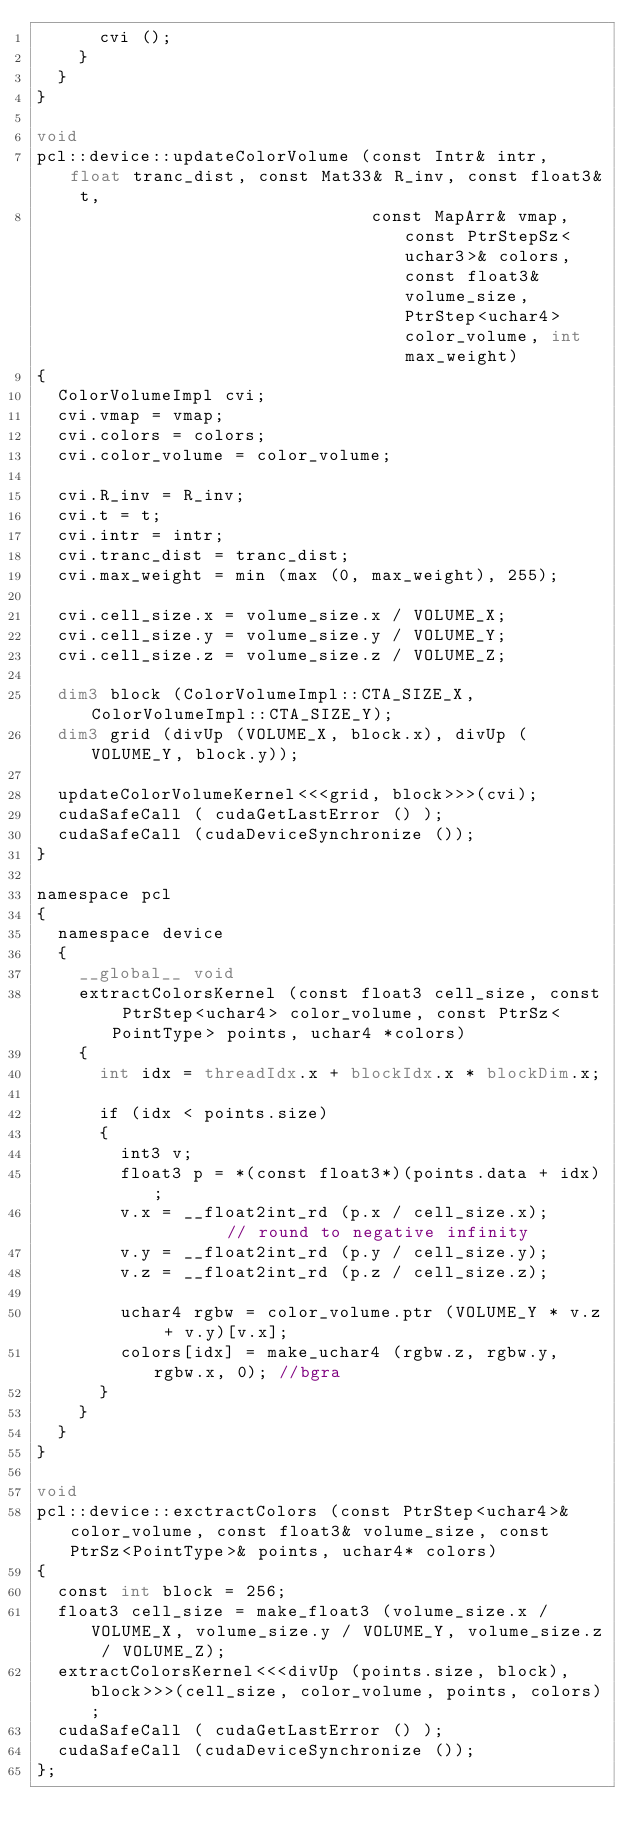Convert code to text. <code><loc_0><loc_0><loc_500><loc_500><_Cuda_>      cvi ();
    }
  }
}

void
pcl::device::updateColorVolume (const Intr& intr, float tranc_dist, const Mat33& R_inv, const float3& t,
                                const MapArr& vmap, const PtrStepSz<uchar3>& colors, const float3& volume_size, PtrStep<uchar4> color_volume, int max_weight)
{
  ColorVolumeImpl cvi;
  cvi.vmap = vmap;
  cvi.colors = colors;
  cvi.color_volume = color_volume;

  cvi.R_inv = R_inv;
  cvi.t = t;
  cvi.intr = intr;
  cvi.tranc_dist = tranc_dist;
  cvi.max_weight = min (max (0, max_weight), 255);

  cvi.cell_size.x = volume_size.x / VOLUME_X;
  cvi.cell_size.y = volume_size.y / VOLUME_Y;
  cvi.cell_size.z = volume_size.z / VOLUME_Z;

  dim3 block (ColorVolumeImpl::CTA_SIZE_X, ColorVolumeImpl::CTA_SIZE_Y);
  dim3 grid (divUp (VOLUME_X, block.x), divUp (VOLUME_Y, block.y));

  updateColorVolumeKernel<<<grid, block>>>(cvi);
  cudaSafeCall ( cudaGetLastError () );
  cudaSafeCall (cudaDeviceSynchronize ());
}

namespace pcl
{
  namespace device
  {
    __global__ void
    extractColorsKernel (const float3 cell_size, const PtrStep<uchar4> color_volume, const PtrSz<PointType> points, uchar4 *colors)
    {
      int idx = threadIdx.x + blockIdx.x * blockDim.x;

      if (idx < points.size)
      {
        int3 v;
        float3 p = *(const float3*)(points.data + idx);
        v.x = __float2int_rd (p.x / cell_size.x);        // round to negative infinity
        v.y = __float2int_rd (p.y / cell_size.y);
        v.z = __float2int_rd (p.z / cell_size.z);

        uchar4 rgbw = color_volume.ptr (VOLUME_Y * v.z + v.y)[v.x];
        colors[idx] = make_uchar4 (rgbw.z, rgbw.y, rgbw.x, 0); //bgra
      }
    }
  }
}

void
pcl::device::exctractColors (const PtrStep<uchar4>& color_volume, const float3& volume_size, const PtrSz<PointType>& points, uchar4* colors)
{
  const int block = 256;
  float3 cell_size = make_float3 (volume_size.x / VOLUME_X, volume_size.y / VOLUME_Y, volume_size.z / VOLUME_Z);
  extractColorsKernel<<<divUp (points.size, block), block>>>(cell_size, color_volume, points, colors);
  cudaSafeCall ( cudaGetLastError () );
  cudaSafeCall (cudaDeviceSynchronize ());
};</code> 